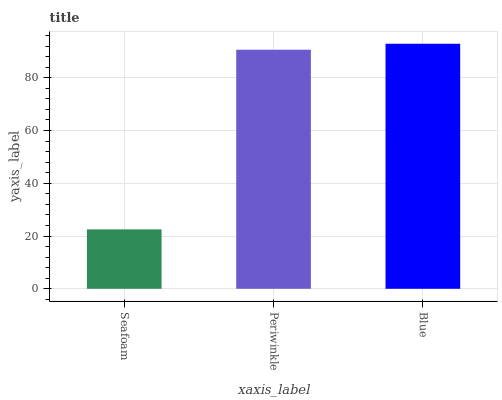Is Seafoam the minimum?
Answer yes or no. Yes. Is Blue the maximum?
Answer yes or no. Yes. Is Periwinkle the minimum?
Answer yes or no. No. Is Periwinkle the maximum?
Answer yes or no. No. Is Periwinkle greater than Seafoam?
Answer yes or no. Yes. Is Seafoam less than Periwinkle?
Answer yes or no. Yes. Is Seafoam greater than Periwinkle?
Answer yes or no. No. Is Periwinkle less than Seafoam?
Answer yes or no. No. Is Periwinkle the high median?
Answer yes or no. Yes. Is Periwinkle the low median?
Answer yes or no. Yes. Is Seafoam the high median?
Answer yes or no. No. Is Blue the low median?
Answer yes or no. No. 